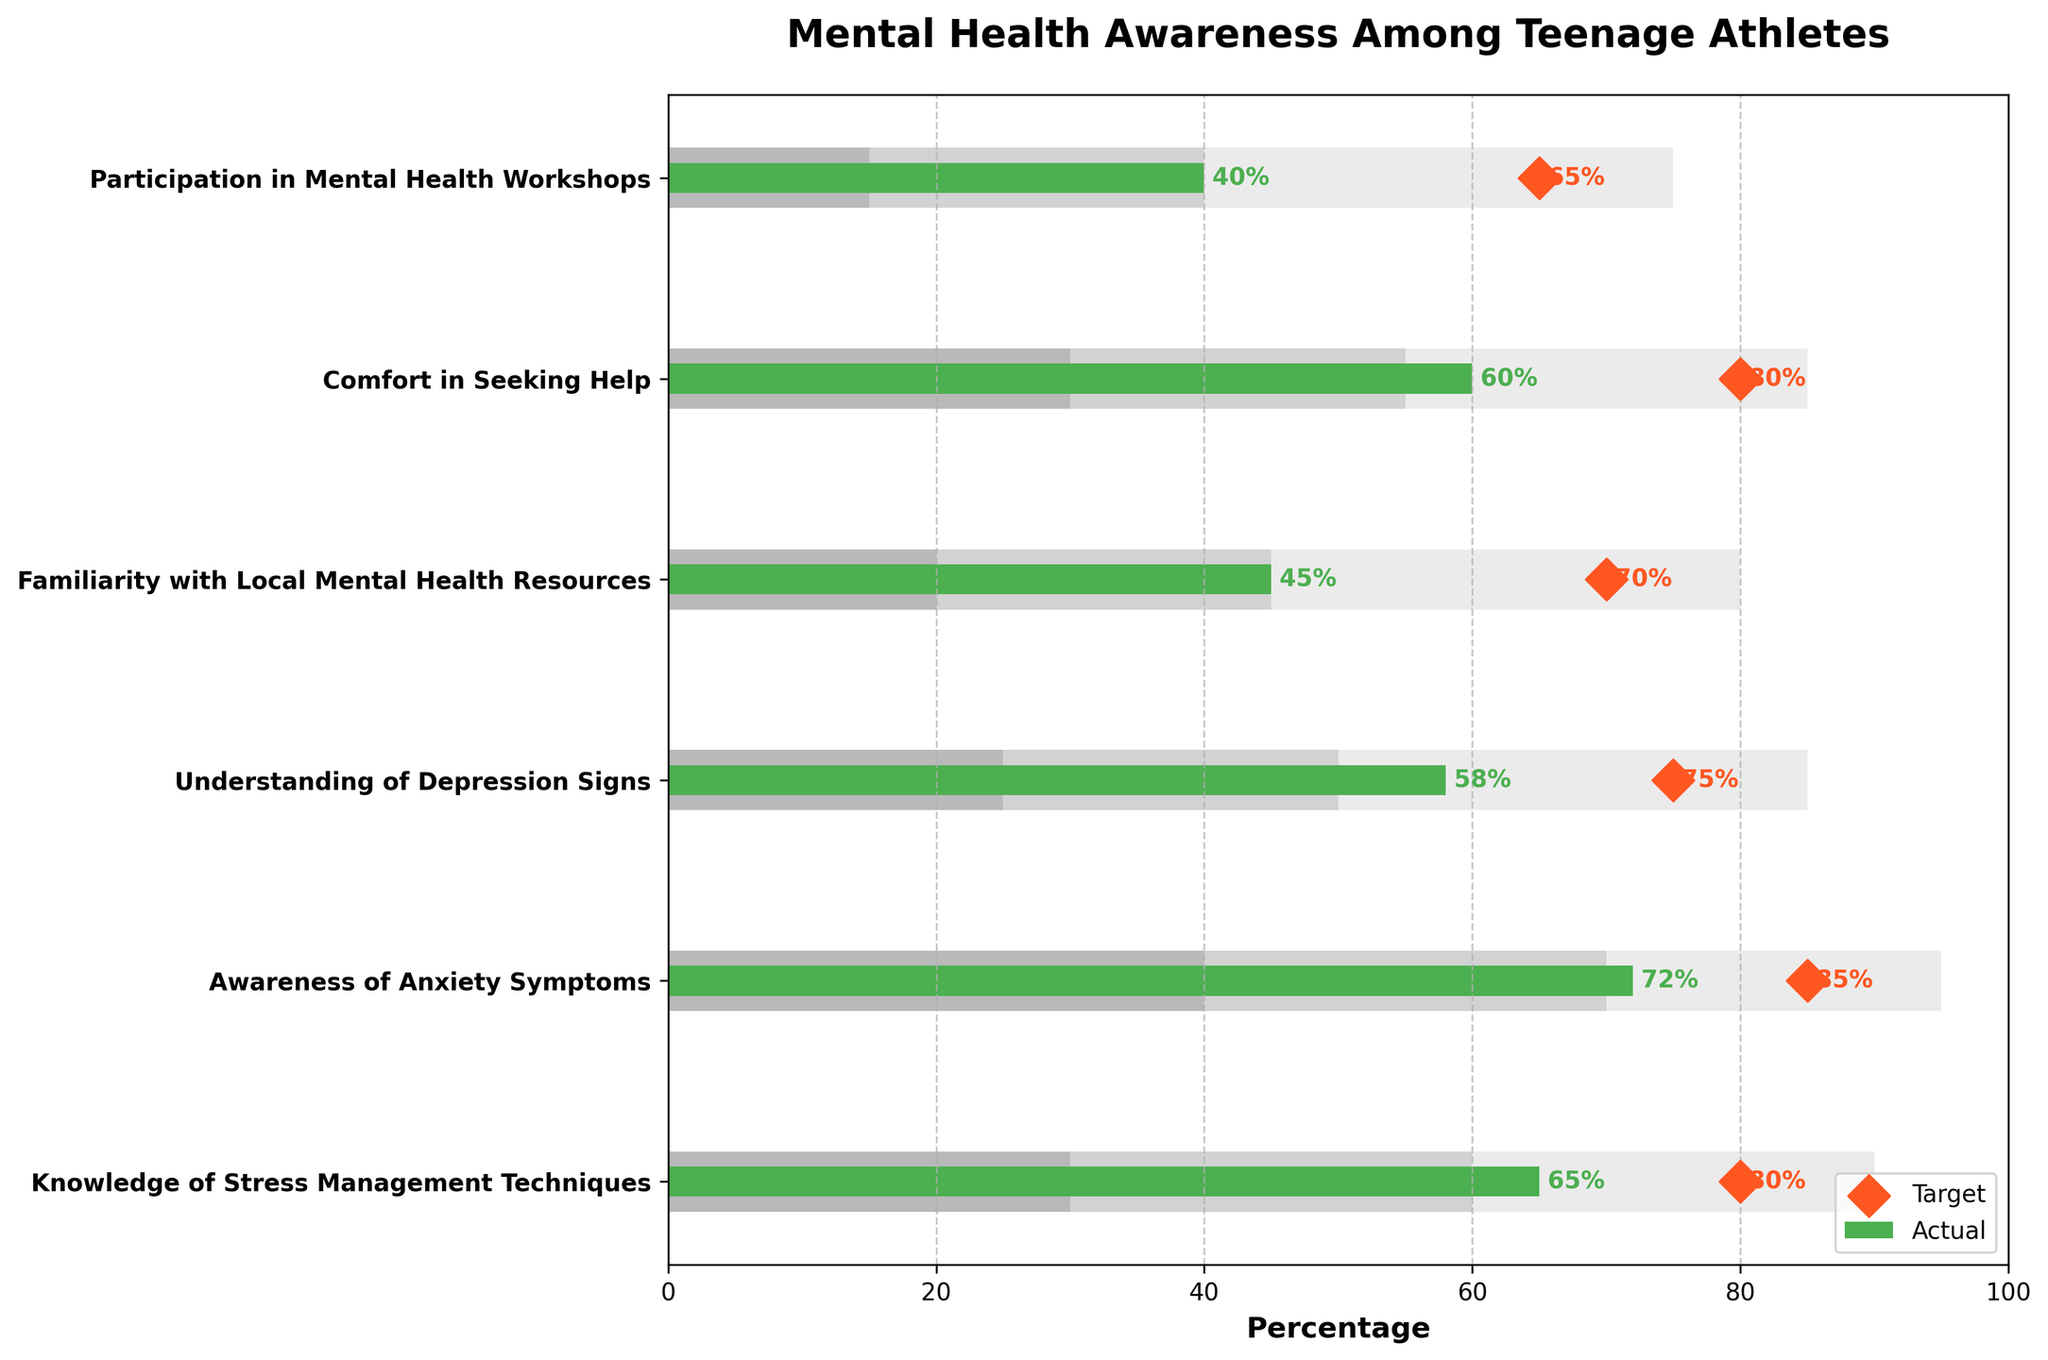What is the title of the plot? The title of the plot is displayed at the top of the figure.
Answer: Mental Health Awareness Among Teenage Athletes How many categories are shown in the plot? Count the number of unique horizontal bars or labels along the y-axis.
Answer: 6 What does the green bar represent in the plot? The green bar represents the actual percentage values for each category, as indicated by the legend.
Answer: Actual What is the target percentage for "Comfort in Seeking Help"? Look for the orange diamond marker next to the "Comfort in Seeking Help" label.
Answer: 80 Which category has the highest actual value? Identify the longest green bar among all categories.
Answer: Awareness of Anxiety Symptoms Which category has the smallest range for Range1? Identify the smallest light grey section width for all categories.
Answer: Participation in Mental Health Workshops What is the difference between the actual and target values for "Understanding of Depression Signs"? Subtract the actual value (58) from the target value (75).
Answer: 17 Which category falls short the most in achieving its target value? Determine the category with the largest difference between the actual and target values.
Answer: Familiarity with Local Mental Health Resources How many categories have actual values within the Range3 boundary? Count the categories where the green bar ends inside the darkest grey range.
Answer: 3 Compare the actual and target values for "Knowledge of Stress Management Techniques". Is the actual value above or below the target? Compare the green bar end and the orange diamond marker for "Knowledge of Stress Management Techniques".
Answer: Below 